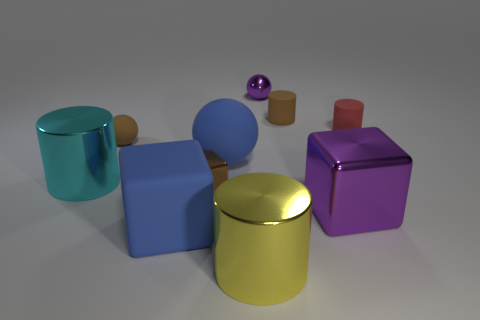What is the shape of the big shiny object that is the same color as the tiny metal sphere?
Keep it short and to the point. Cube. Is there a large object of the same color as the small shiny sphere?
Keep it short and to the point. Yes. Are there an equal number of large metal blocks behind the big purple metallic thing and red cylinders that are in front of the blue matte cube?
Your answer should be very brief. Yes. There is a brown rubber thing that is on the right side of the blue ball; does it have the same shape as the purple metallic thing that is in front of the small matte ball?
Keep it short and to the point. No. What is the shape of the cyan object that is the same material as the large yellow thing?
Offer a very short reply. Cylinder. Are there an equal number of large purple metallic blocks that are behind the shiny sphere and small balls?
Provide a succinct answer. No. Are the small cylinder in front of the tiny brown rubber cylinder and the blue object in front of the cyan cylinder made of the same material?
Keep it short and to the point. Yes. What is the shape of the tiny metal object behind the matte object that is right of the brown matte cylinder?
Your answer should be very brief. Sphere. The other cylinder that is made of the same material as the big cyan cylinder is what color?
Provide a short and direct response. Yellow. Is the color of the tiny cube the same as the small matte ball?
Your answer should be very brief. Yes. 